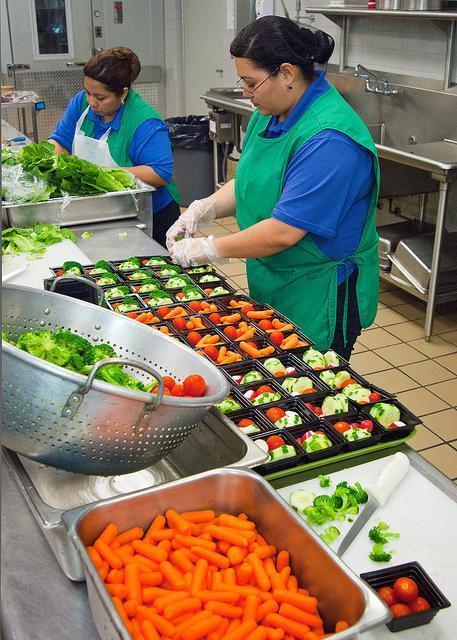How many people are there?
Give a very brief answer. 2. How many sinks can you see?
Give a very brief answer. 1. How many broccolis can be seen?
Give a very brief answer. 1. How many carrots are in the photo?
Give a very brief answer. 2. 